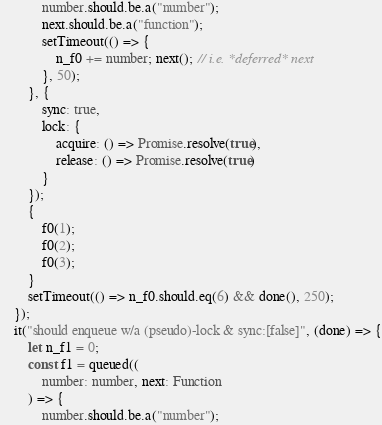Convert code to text. <code><loc_0><loc_0><loc_500><loc_500><_TypeScript_>            number.should.be.a("number");
            next.should.be.a("function");
            setTimeout(() => {
                n_f0 += number; next(); // i.e. *deferred* next
            }, 50);
        }, {
            sync: true,
            lock: {
                acquire: () => Promise.resolve(true),
                release: () => Promise.resolve(true)
            }
        });
        {
            f0(1);
            f0(2);
            f0(3);
        }
        setTimeout(() => n_f0.should.eq(6) && done(), 250);
    });
    it("should enqueue w/a (pseudo)-lock & sync:[false]", (done) => {
        let n_f1 = 0;
        const f1 = queued((
            number: number, next: Function
        ) => {
            number.should.be.a("number");</code> 